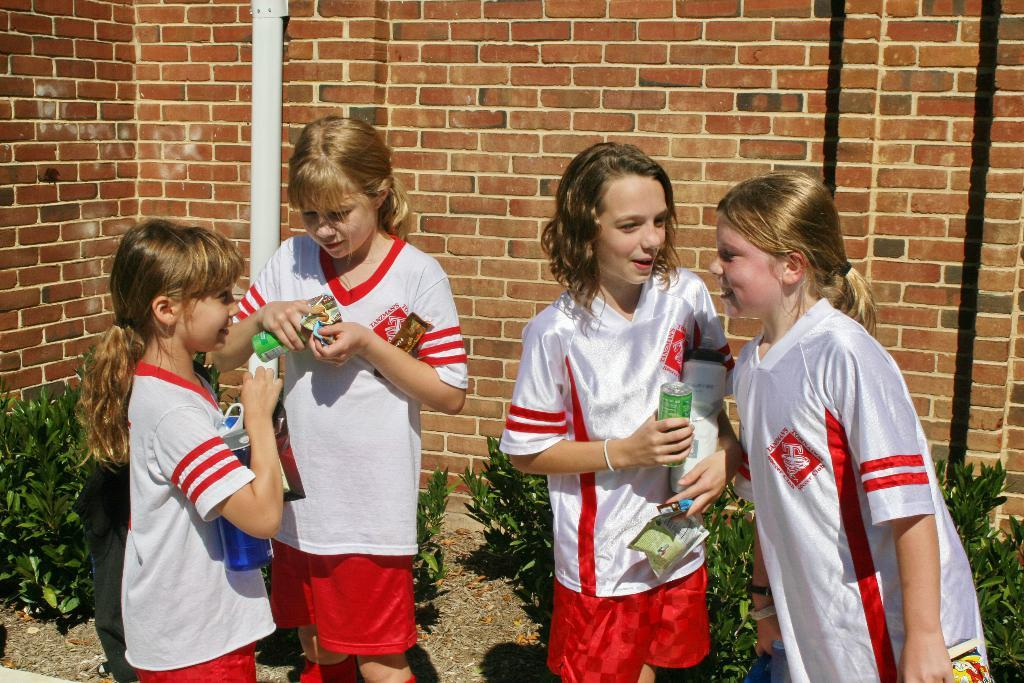How many children are in the image? There are four children in the image. What are the children wearing? The children are wearing white t-shirts. What are the children doing in the image? The children are standing. What can be seen in the background of the image? There are plants on the ground and a pipe attached to a brick wall in the background of the image. What type of desk can be seen in the image? There is no desk present in the image. What thoughts are the children having while standing in the image? We cannot determine the thoughts of the children from the image, as thoughts are not visible. 